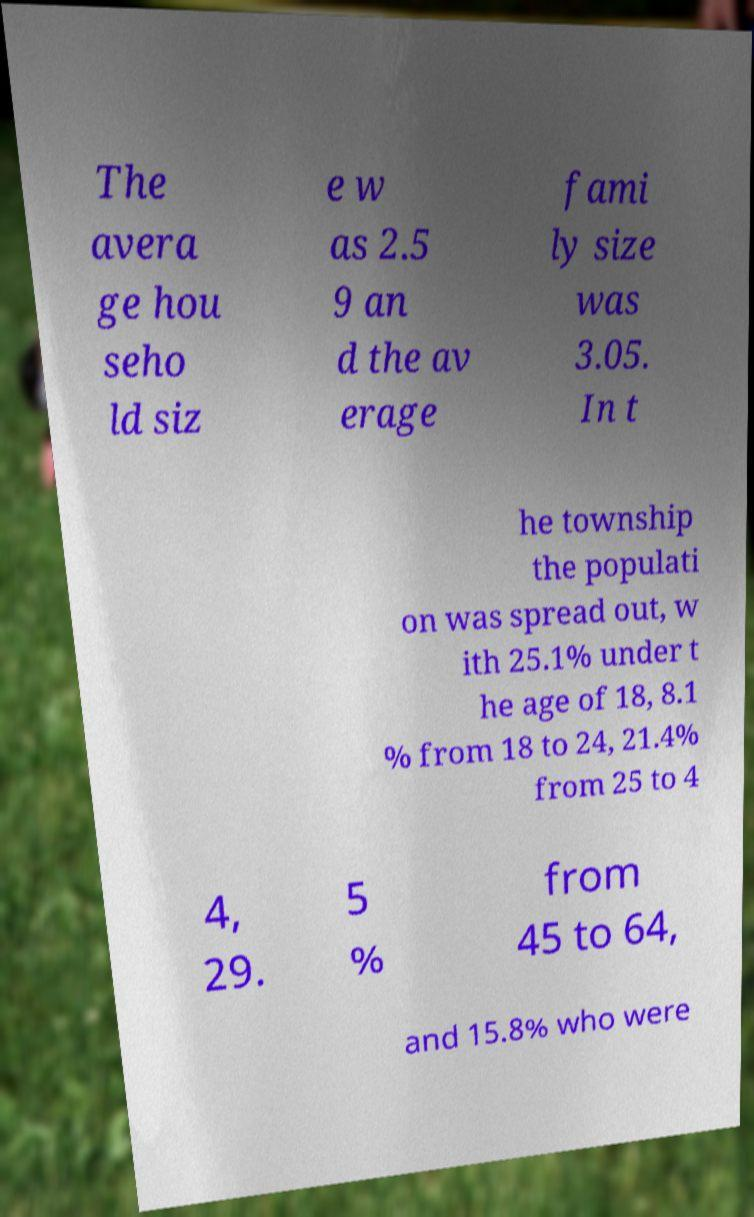Could you assist in decoding the text presented in this image and type it out clearly? The avera ge hou seho ld siz e w as 2.5 9 an d the av erage fami ly size was 3.05. In t he township the populati on was spread out, w ith 25.1% under t he age of 18, 8.1 % from 18 to 24, 21.4% from 25 to 4 4, 29. 5 % from 45 to 64, and 15.8% who were 